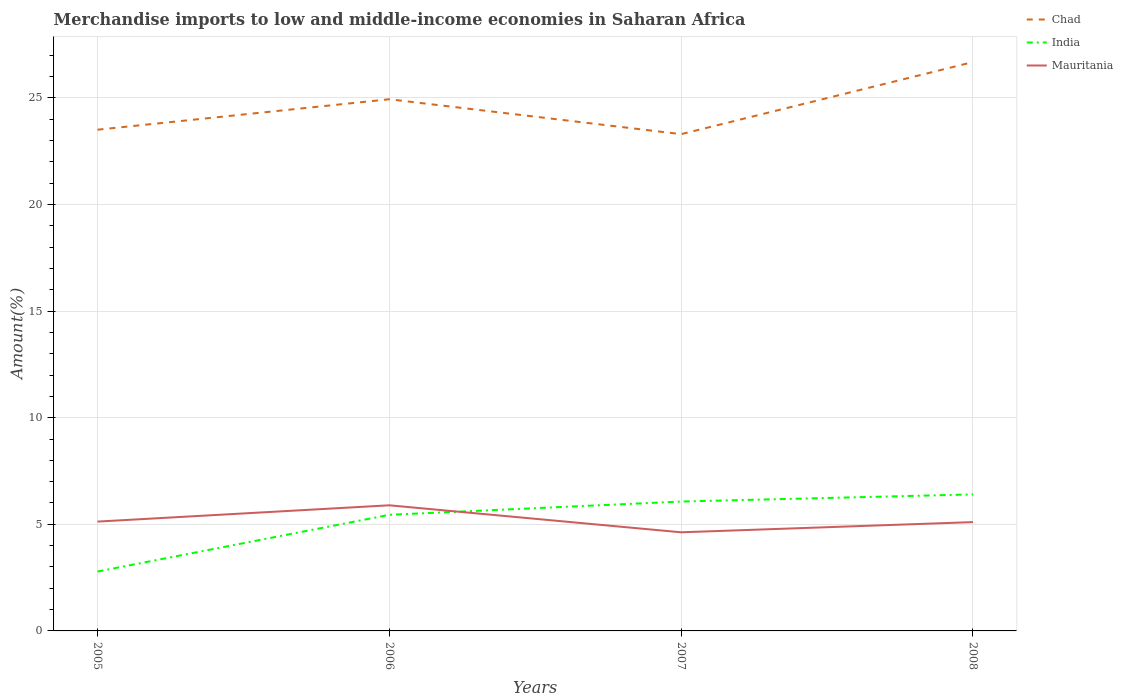How many different coloured lines are there?
Make the answer very short. 3. Does the line corresponding to Chad intersect with the line corresponding to India?
Offer a terse response. No. Is the number of lines equal to the number of legend labels?
Ensure brevity in your answer.  Yes. Across all years, what is the maximum percentage of amount earned from merchandise imports in Mauritania?
Your answer should be compact. 4.63. What is the total percentage of amount earned from merchandise imports in Mauritania in the graph?
Provide a short and direct response. -0.48. What is the difference between the highest and the second highest percentage of amount earned from merchandise imports in Mauritania?
Your answer should be compact. 1.27. How many years are there in the graph?
Ensure brevity in your answer.  4. What is the difference between two consecutive major ticks on the Y-axis?
Give a very brief answer. 5. Are the values on the major ticks of Y-axis written in scientific E-notation?
Ensure brevity in your answer.  No. Does the graph contain grids?
Your response must be concise. Yes. How many legend labels are there?
Provide a succinct answer. 3. How are the legend labels stacked?
Ensure brevity in your answer.  Vertical. What is the title of the graph?
Your answer should be compact. Merchandise imports to low and middle-income economies in Saharan Africa. Does "Israel" appear as one of the legend labels in the graph?
Your answer should be very brief. No. What is the label or title of the Y-axis?
Provide a succinct answer. Amount(%). What is the Amount(%) in Chad in 2005?
Offer a terse response. 23.51. What is the Amount(%) in India in 2005?
Provide a succinct answer. 2.79. What is the Amount(%) in Mauritania in 2005?
Your response must be concise. 5.13. What is the Amount(%) in Chad in 2006?
Your answer should be very brief. 24.93. What is the Amount(%) of India in 2006?
Offer a terse response. 5.45. What is the Amount(%) in Mauritania in 2006?
Offer a very short reply. 5.89. What is the Amount(%) of Chad in 2007?
Make the answer very short. 23.3. What is the Amount(%) of India in 2007?
Keep it short and to the point. 6.07. What is the Amount(%) of Mauritania in 2007?
Your response must be concise. 4.63. What is the Amount(%) in Chad in 2008?
Offer a terse response. 26.68. What is the Amount(%) of India in 2008?
Provide a short and direct response. 6.4. What is the Amount(%) of Mauritania in 2008?
Your response must be concise. 5.1. Across all years, what is the maximum Amount(%) of Chad?
Offer a terse response. 26.68. Across all years, what is the maximum Amount(%) in India?
Make the answer very short. 6.4. Across all years, what is the maximum Amount(%) in Mauritania?
Give a very brief answer. 5.89. Across all years, what is the minimum Amount(%) of Chad?
Provide a succinct answer. 23.3. Across all years, what is the minimum Amount(%) in India?
Offer a terse response. 2.79. Across all years, what is the minimum Amount(%) of Mauritania?
Provide a succinct answer. 4.63. What is the total Amount(%) of Chad in the graph?
Your answer should be very brief. 98.42. What is the total Amount(%) of India in the graph?
Give a very brief answer. 20.7. What is the total Amount(%) in Mauritania in the graph?
Offer a very short reply. 20.75. What is the difference between the Amount(%) of Chad in 2005 and that in 2006?
Offer a terse response. -1.43. What is the difference between the Amount(%) of India in 2005 and that in 2006?
Provide a succinct answer. -2.66. What is the difference between the Amount(%) in Mauritania in 2005 and that in 2006?
Provide a succinct answer. -0.76. What is the difference between the Amount(%) of Chad in 2005 and that in 2007?
Offer a terse response. 0.21. What is the difference between the Amount(%) of India in 2005 and that in 2007?
Provide a short and direct response. -3.28. What is the difference between the Amount(%) in Mauritania in 2005 and that in 2007?
Give a very brief answer. 0.5. What is the difference between the Amount(%) of Chad in 2005 and that in 2008?
Offer a very short reply. -3.17. What is the difference between the Amount(%) of India in 2005 and that in 2008?
Your answer should be very brief. -3.62. What is the difference between the Amount(%) in Mauritania in 2005 and that in 2008?
Your response must be concise. 0.02. What is the difference between the Amount(%) in Chad in 2006 and that in 2007?
Your answer should be very brief. 1.64. What is the difference between the Amount(%) in India in 2006 and that in 2007?
Give a very brief answer. -0.62. What is the difference between the Amount(%) in Mauritania in 2006 and that in 2007?
Keep it short and to the point. 1.27. What is the difference between the Amount(%) of Chad in 2006 and that in 2008?
Your answer should be compact. -1.74. What is the difference between the Amount(%) in India in 2006 and that in 2008?
Ensure brevity in your answer.  -0.96. What is the difference between the Amount(%) of Mauritania in 2006 and that in 2008?
Offer a very short reply. 0.79. What is the difference between the Amount(%) of Chad in 2007 and that in 2008?
Your answer should be compact. -3.38. What is the difference between the Amount(%) in India in 2007 and that in 2008?
Offer a terse response. -0.33. What is the difference between the Amount(%) of Mauritania in 2007 and that in 2008?
Keep it short and to the point. -0.48. What is the difference between the Amount(%) in Chad in 2005 and the Amount(%) in India in 2006?
Offer a terse response. 18.06. What is the difference between the Amount(%) of Chad in 2005 and the Amount(%) of Mauritania in 2006?
Offer a very short reply. 17.61. What is the difference between the Amount(%) of India in 2005 and the Amount(%) of Mauritania in 2006?
Keep it short and to the point. -3.11. What is the difference between the Amount(%) in Chad in 2005 and the Amount(%) in India in 2007?
Your answer should be very brief. 17.44. What is the difference between the Amount(%) in Chad in 2005 and the Amount(%) in Mauritania in 2007?
Your answer should be very brief. 18.88. What is the difference between the Amount(%) in India in 2005 and the Amount(%) in Mauritania in 2007?
Provide a short and direct response. -1.84. What is the difference between the Amount(%) in Chad in 2005 and the Amount(%) in India in 2008?
Offer a very short reply. 17.1. What is the difference between the Amount(%) in Chad in 2005 and the Amount(%) in Mauritania in 2008?
Your answer should be very brief. 18.4. What is the difference between the Amount(%) of India in 2005 and the Amount(%) of Mauritania in 2008?
Ensure brevity in your answer.  -2.32. What is the difference between the Amount(%) of Chad in 2006 and the Amount(%) of India in 2007?
Provide a succinct answer. 18.87. What is the difference between the Amount(%) of Chad in 2006 and the Amount(%) of Mauritania in 2007?
Your answer should be very brief. 20.31. What is the difference between the Amount(%) in India in 2006 and the Amount(%) in Mauritania in 2007?
Ensure brevity in your answer.  0.82. What is the difference between the Amount(%) of Chad in 2006 and the Amount(%) of India in 2008?
Provide a succinct answer. 18.53. What is the difference between the Amount(%) in Chad in 2006 and the Amount(%) in Mauritania in 2008?
Keep it short and to the point. 19.83. What is the difference between the Amount(%) in India in 2006 and the Amount(%) in Mauritania in 2008?
Offer a very short reply. 0.34. What is the difference between the Amount(%) in Chad in 2007 and the Amount(%) in India in 2008?
Keep it short and to the point. 16.9. What is the difference between the Amount(%) of Chad in 2007 and the Amount(%) of Mauritania in 2008?
Provide a succinct answer. 18.19. What is the difference between the Amount(%) of India in 2007 and the Amount(%) of Mauritania in 2008?
Your answer should be very brief. 0.96. What is the average Amount(%) in Chad per year?
Provide a short and direct response. 24.6. What is the average Amount(%) of India per year?
Offer a very short reply. 5.18. What is the average Amount(%) of Mauritania per year?
Offer a very short reply. 5.19. In the year 2005, what is the difference between the Amount(%) in Chad and Amount(%) in India?
Your answer should be very brief. 20.72. In the year 2005, what is the difference between the Amount(%) of Chad and Amount(%) of Mauritania?
Keep it short and to the point. 18.38. In the year 2005, what is the difference between the Amount(%) in India and Amount(%) in Mauritania?
Offer a terse response. -2.34. In the year 2006, what is the difference between the Amount(%) in Chad and Amount(%) in India?
Your answer should be compact. 19.49. In the year 2006, what is the difference between the Amount(%) of Chad and Amount(%) of Mauritania?
Provide a short and direct response. 19.04. In the year 2006, what is the difference between the Amount(%) of India and Amount(%) of Mauritania?
Provide a succinct answer. -0.45. In the year 2007, what is the difference between the Amount(%) in Chad and Amount(%) in India?
Keep it short and to the point. 17.23. In the year 2007, what is the difference between the Amount(%) of Chad and Amount(%) of Mauritania?
Make the answer very short. 18.67. In the year 2007, what is the difference between the Amount(%) in India and Amount(%) in Mauritania?
Your answer should be compact. 1.44. In the year 2008, what is the difference between the Amount(%) of Chad and Amount(%) of India?
Your answer should be compact. 20.28. In the year 2008, what is the difference between the Amount(%) of Chad and Amount(%) of Mauritania?
Make the answer very short. 21.58. In the year 2008, what is the difference between the Amount(%) in India and Amount(%) in Mauritania?
Give a very brief answer. 1.3. What is the ratio of the Amount(%) in Chad in 2005 to that in 2006?
Your response must be concise. 0.94. What is the ratio of the Amount(%) of India in 2005 to that in 2006?
Keep it short and to the point. 0.51. What is the ratio of the Amount(%) of Mauritania in 2005 to that in 2006?
Your answer should be very brief. 0.87. What is the ratio of the Amount(%) of Chad in 2005 to that in 2007?
Your answer should be compact. 1.01. What is the ratio of the Amount(%) in India in 2005 to that in 2007?
Make the answer very short. 0.46. What is the ratio of the Amount(%) of Mauritania in 2005 to that in 2007?
Keep it short and to the point. 1.11. What is the ratio of the Amount(%) of Chad in 2005 to that in 2008?
Ensure brevity in your answer.  0.88. What is the ratio of the Amount(%) of India in 2005 to that in 2008?
Your answer should be very brief. 0.44. What is the ratio of the Amount(%) of Chad in 2006 to that in 2007?
Give a very brief answer. 1.07. What is the ratio of the Amount(%) of India in 2006 to that in 2007?
Your response must be concise. 0.9. What is the ratio of the Amount(%) of Mauritania in 2006 to that in 2007?
Provide a short and direct response. 1.27. What is the ratio of the Amount(%) of Chad in 2006 to that in 2008?
Your answer should be very brief. 0.93. What is the ratio of the Amount(%) of India in 2006 to that in 2008?
Give a very brief answer. 0.85. What is the ratio of the Amount(%) in Mauritania in 2006 to that in 2008?
Your answer should be very brief. 1.15. What is the ratio of the Amount(%) in Chad in 2007 to that in 2008?
Provide a short and direct response. 0.87. What is the ratio of the Amount(%) of India in 2007 to that in 2008?
Your answer should be very brief. 0.95. What is the ratio of the Amount(%) of Mauritania in 2007 to that in 2008?
Your answer should be very brief. 0.91. What is the difference between the highest and the second highest Amount(%) of Chad?
Keep it short and to the point. 1.74. What is the difference between the highest and the second highest Amount(%) in India?
Ensure brevity in your answer.  0.33. What is the difference between the highest and the second highest Amount(%) in Mauritania?
Offer a very short reply. 0.76. What is the difference between the highest and the lowest Amount(%) of Chad?
Your answer should be compact. 3.38. What is the difference between the highest and the lowest Amount(%) in India?
Provide a short and direct response. 3.62. What is the difference between the highest and the lowest Amount(%) of Mauritania?
Your response must be concise. 1.27. 